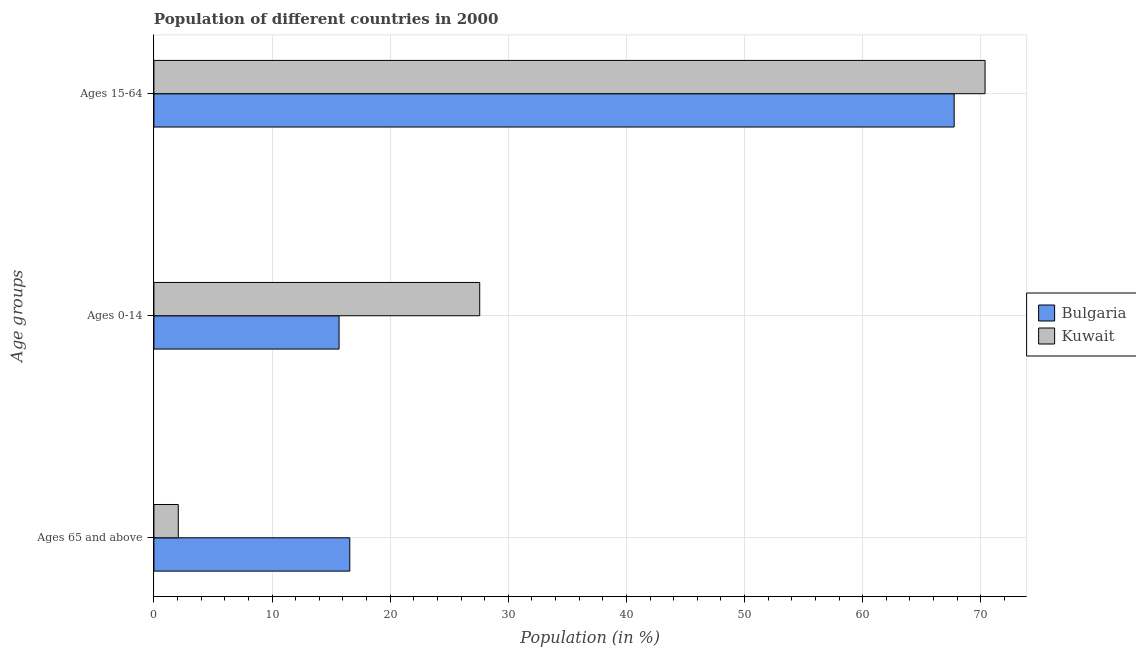How many groups of bars are there?
Give a very brief answer. 3. How many bars are there on the 2nd tick from the top?
Your response must be concise. 2. How many bars are there on the 1st tick from the bottom?
Give a very brief answer. 2. What is the label of the 2nd group of bars from the top?
Provide a short and direct response. Ages 0-14. What is the percentage of population within the age-group 0-14 in Bulgaria?
Offer a terse response. 15.67. Across all countries, what is the maximum percentage of population within the age-group of 65 and above?
Your answer should be compact. 16.58. Across all countries, what is the minimum percentage of population within the age-group of 65 and above?
Ensure brevity in your answer.  2.06. In which country was the percentage of population within the age-group 0-14 maximum?
Your answer should be compact. Kuwait. What is the total percentage of population within the age-group 15-64 in the graph?
Make the answer very short. 138.1. What is the difference between the percentage of population within the age-group 0-14 in Bulgaria and that in Kuwait?
Offer a terse response. -11.91. What is the difference between the percentage of population within the age-group of 65 and above in Kuwait and the percentage of population within the age-group 0-14 in Bulgaria?
Make the answer very short. -13.61. What is the average percentage of population within the age-group 15-64 per country?
Your response must be concise. 69.05. What is the difference between the percentage of population within the age-group 15-64 and percentage of population within the age-group 0-14 in Bulgaria?
Offer a terse response. 52.07. What is the ratio of the percentage of population within the age-group 0-14 in Kuwait to that in Bulgaria?
Offer a very short reply. 1.76. Is the difference between the percentage of population within the age-group 0-14 in Kuwait and Bulgaria greater than the difference between the percentage of population within the age-group of 65 and above in Kuwait and Bulgaria?
Your answer should be very brief. Yes. What is the difference between the highest and the second highest percentage of population within the age-group 0-14?
Provide a succinct answer. 11.91. What is the difference between the highest and the lowest percentage of population within the age-group 0-14?
Your answer should be compact. 11.91. In how many countries, is the percentage of population within the age-group of 65 and above greater than the average percentage of population within the age-group of 65 and above taken over all countries?
Your answer should be very brief. 1. Is the sum of the percentage of population within the age-group 15-64 in Kuwait and Bulgaria greater than the maximum percentage of population within the age-group of 65 and above across all countries?
Provide a short and direct response. Yes. What does the 2nd bar from the top in Ages 65 and above represents?
Your answer should be very brief. Bulgaria. What does the 2nd bar from the bottom in Ages 65 and above represents?
Provide a succinct answer. Kuwait. What is the difference between two consecutive major ticks on the X-axis?
Make the answer very short. 10. Does the graph contain grids?
Ensure brevity in your answer.  Yes. Where does the legend appear in the graph?
Your answer should be compact. Center right. How many legend labels are there?
Make the answer very short. 2. How are the legend labels stacked?
Offer a terse response. Vertical. What is the title of the graph?
Ensure brevity in your answer.  Population of different countries in 2000. What is the label or title of the X-axis?
Keep it short and to the point. Population (in %). What is the label or title of the Y-axis?
Provide a short and direct response. Age groups. What is the Population (in %) in Bulgaria in Ages 65 and above?
Provide a short and direct response. 16.58. What is the Population (in %) in Kuwait in Ages 65 and above?
Offer a terse response. 2.06. What is the Population (in %) in Bulgaria in Ages 0-14?
Your answer should be compact. 15.67. What is the Population (in %) of Kuwait in Ages 0-14?
Your answer should be very brief. 27.58. What is the Population (in %) of Bulgaria in Ages 15-64?
Your answer should be compact. 67.74. What is the Population (in %) in Kuwait in Ages 15-64?
Provide a succinct answer. 70.36. Across all Age groups, what is the maximum Population (in %) in Bulgaria?
Provide a succinct answer. 67.74. Across all Age groups, what is the maximum Population (in %) in Kuwait?
Provide a short and direct response. 70.36. Across all Age groups, what is the minimum Population (in %) of Bulgaria?
Your response must be concise. 15.67. Across all Age groups, what is the minimum Population (in %) in Kuwait?
Keep it short and to the point. 2.06. What is the difference between the Population (in %) of Bulgaria in Ages 65 and above and that in Ages 0-14?
Give a very brief answer. 0.91. What is the difference between the Population (in %) in Kuwait in Ages 65 and above and that in Ages 0-14?
Your answer should be compact. -25.52. What is the difference between the Population (in %) of Bulgaria in Ages 65 and above and that in Ages 15-64?
Keep it short and to the point. -51.16. What is the difference between the Population (in %) of Kuwait in Ages 65 and above and that in Ages 15-64?
Your answer should be compact. -68.3. What is the difference between the Population (in %) of Bulgaria in Ages 0-14 and that in Ages 15-64?
Provide a succinct answer. -52.07. What is the difference between the Population (in %) of Kuwait in Ages 0-14 and that in Ages 15-64?
Provide a succinct answer. -42.78. What is the difference between the Population (in %) in Bulgaria in Ages 65 and above and the Population (in %) in Kuwait in Ages 0-14?
Offer a very short reply. -11. What is the difference between the Population (in %) in Bulgaria in Ages 65 and above and the Population (in %) in Kuwait in Ages 15-64?
Give a very brief answer. -53.78. What is the difference between the Population (in %) of Bulgaria in Ages 0-14 and the Population (in %) of Kuwait in Ages 15-64?
Provide a short and direct response. -54.69. What is the average Population (in %) in Bulgaria per Age groups?
Make the answer very short. 33.33. What is the average Population (in %) of Kuwait per Age groups?
Your answer should be very brief. 33.33. What is the difference between the Population (in %) of Bulgaria and Population (in %) of Kuwait in Ages 65 and above?
Your response must be concise. 14.52. What is the difference between the Population (in %) of Bulgaria and Population (in %) of Kuwait in Ages 0-14?
Provide a succinct answer. -11.91. What is the difference between the Population (in %) in Bulgaria and Population (in %) in Kuwait in Ages 15-64?
Your answer should be compact. -2.61. What is the ratio of the Population (in %) of Bulgaria in Ages 65 and above to that in Ages 0-14?
Your answer should be very brief. 1.06. What is the ratio of the Population (in %) of Kuwait in Ages 65 and above to that in Ages 0-14?
Your response must be concise. 0.07. What is the ratio of the Population (in %) in Bulgaria in Ages 65 and above to that in Ages 15-64?
Your answer should be compact. 0.24. What is the ratio of the Population (in %) of Kuwait in Ages 65 and above to that in Ages 15-64?
Make the answer very short. 0.03. What is the ratio of the Population (in %) of Bulgaria in Ages 0-14 to that in Ages 15-64?
Offer a terse response. 0.23. What is the ratio of the Population (in %) of Kuwait in Ages 0-14 to that in Ages 15-64?
Ensure brevity in your answer.  0.39. What is the difference between the highest and the second highest Population (in %) in Bulgaria?
Keep it short and to the point. 51.16. What is the difference between the highest and the second highest Population (in %) of Kuwait?
Provide a short and direct response. 42.78. What is the difference between the highest and the lowest Population (in %) of Bulgaria?
Offer a very short reply. 52.07. What is the difference between the highest and the lowest Population (in %) of Kuwait?
Your answer should be compact. 68.3. 